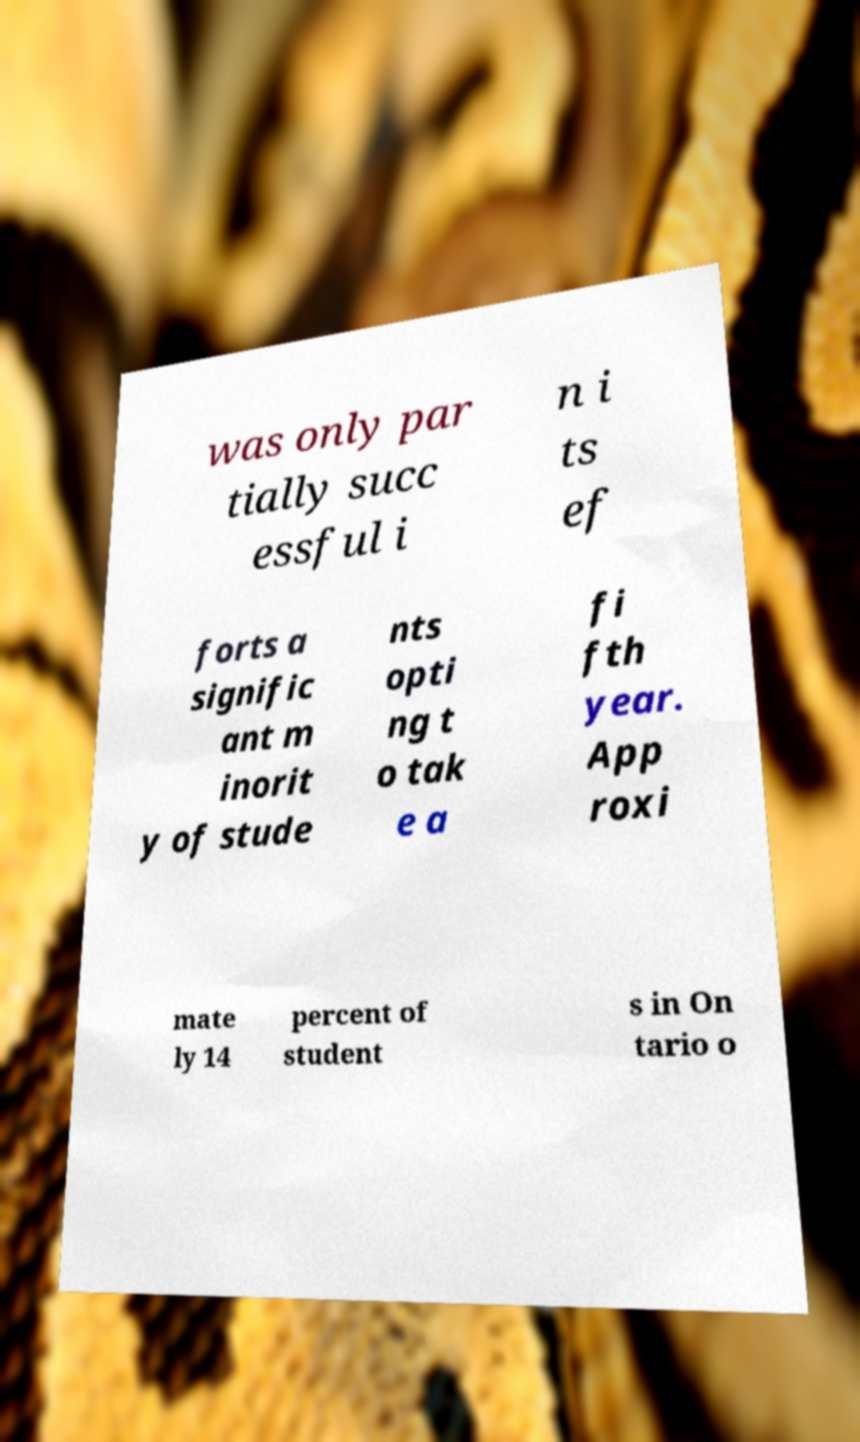Can you accurately transcribe the text from the provided image for me? was only par tially succ essful i n i ts ef forts a signific ant m inorit y of stude nts opti ng t o tak e a fi fth year. App roxi mate ly 14 percent of student s in On tario o 